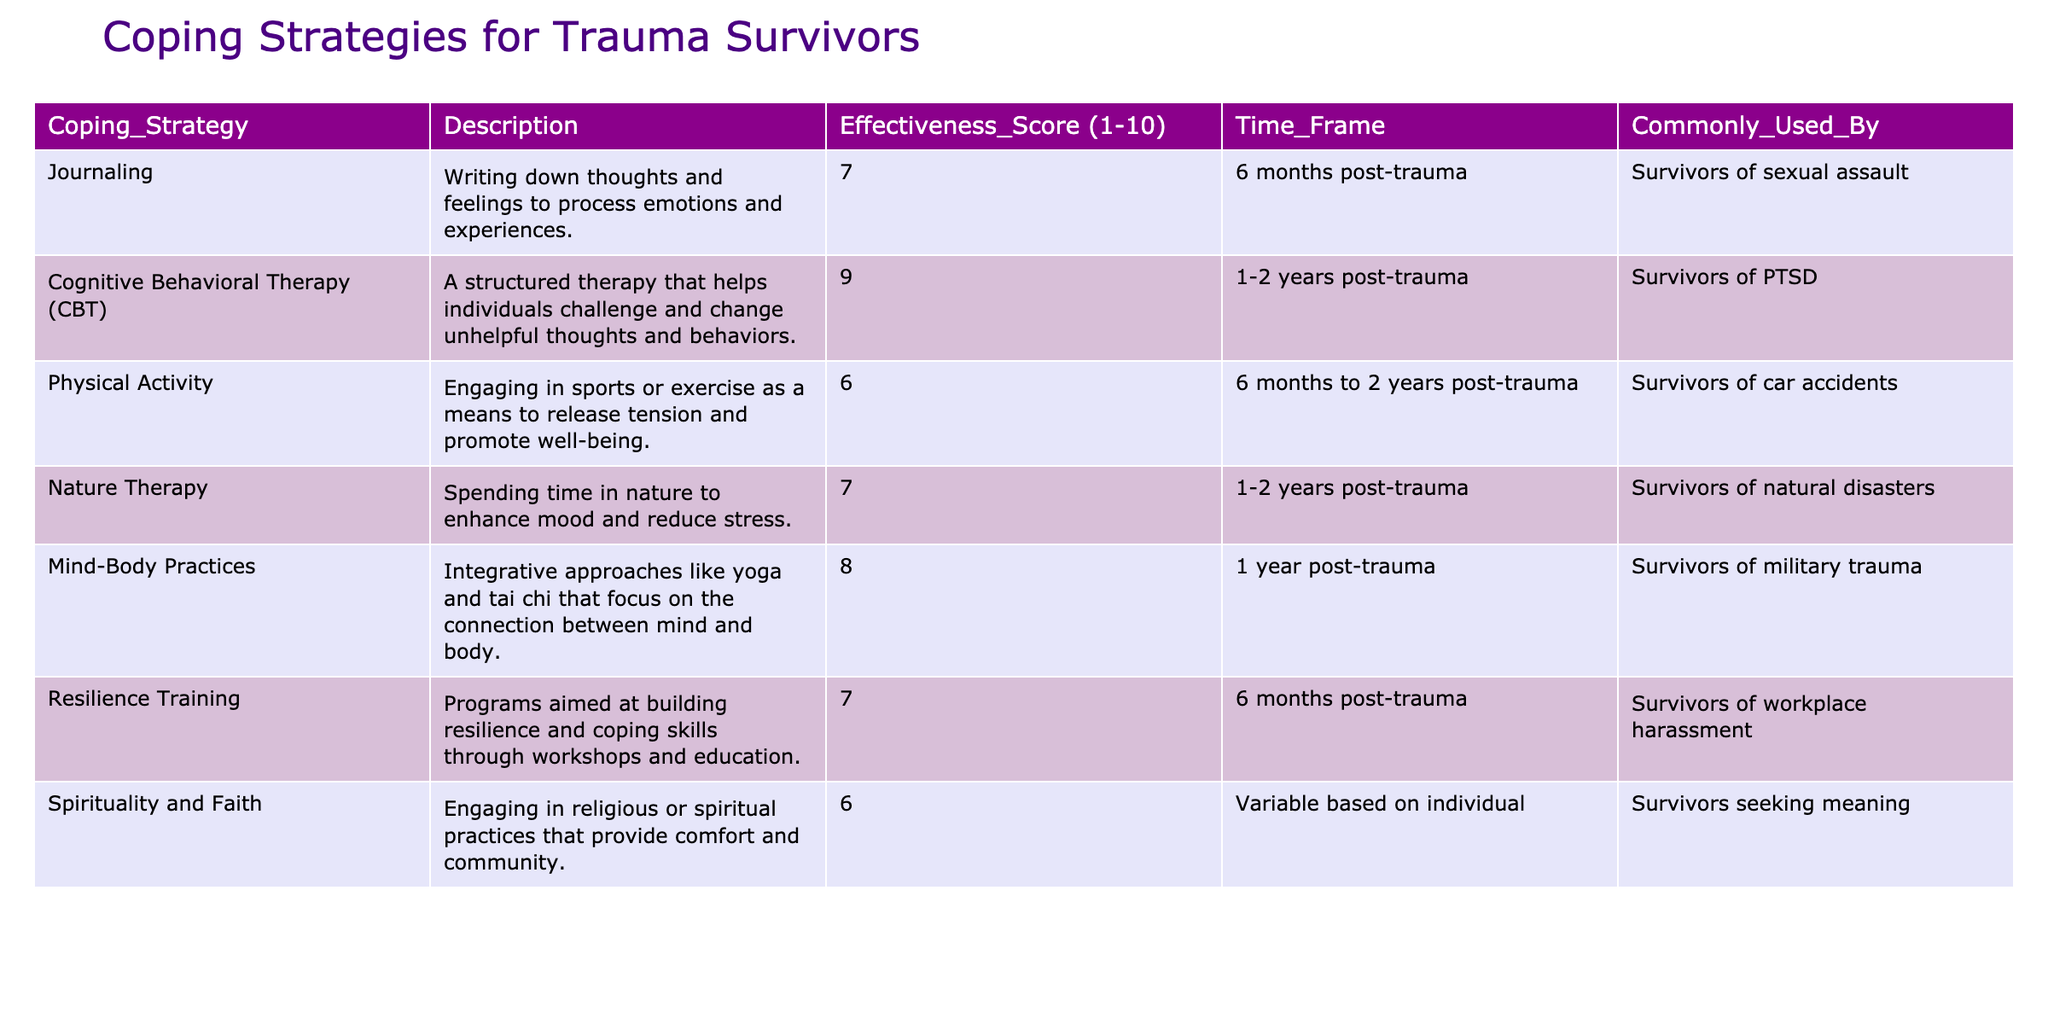What is the effectiveness score of Cognitive Behavioral Therapy (CBT)? The table lists the effectiveness score for CBT as 9.
Answer: 9 Which coping strategy is commonly used by survivors of sexual assault? According to the table, Journaling is commonly used by survivors of sexual assault.
Answer: Journaling How many coping strategies have an effectiveness score of 7? The table shows that Journaling, Resilience Training, and Nature Therapy all have an effectiveness score of 7, totaling three strategies.
Answer: 3 Is Physical Activity used by survivors of military trauma? The table indicates that Physical Activity is used by survivors of car accidents, not military trauma, making this statement false.
Answer: No Which coping strategy has the highest effectiveness score and is common for PTSD survivors? The table specifies that Cognitive Behavioral Therapy (CBT) has the highest effectiveness score of 9 and is common for PTSD survivors.
Answer: Cognitive Behavioral Therapy (CBT) What is the average effectiveness score of the coping strategies listed in the table? The effectiveness scores are 7, 9, 6, 7, 8, 7, and 6. Summing these gives 50, and dividing by 7 strategies gives an average of approximately 7.14.
Answer: Approximately 7.14 For how long after trauma is Mind-Body Practices commonly used? Mind-Body Practices are mentioned as being used 1 year post-trauma in the table.
Answer: 1 year Which coping strategy is described as promoting well-being through sports or exercise? The table describes Physical Activity as engaging in sports or exercise to promote well-being.
Answer: Physical Activity Are there any coping strategies with a score lower than 7 that are commonly used by survivors seeking meaning? The table shows that Spirituality and Faith has an effectiveness score of 6 and is commonly used by survivors seeking meaning, confirming this statement as true.
Answer: Yes What is the difference between the effectiveness scores of Nature Therapy and Physical Activity? Nature Therapy has an effectiveness score of 7, while Physical Activity has a score of 6. The difference between 7 and 6 is 1.
Answer: 1 